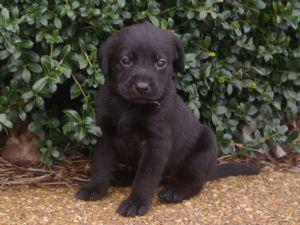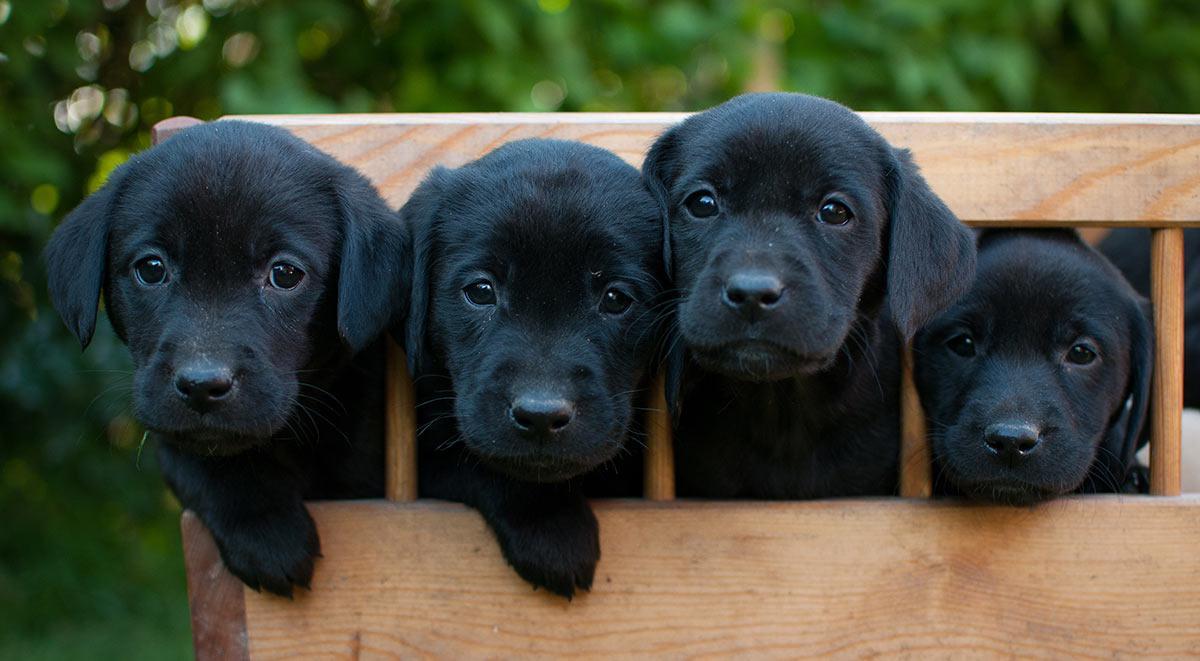The first image is the image on the left, the second image is the image on the right. Evaluate the accuracy of this statement regarding the images: "In one image, one adult dog has its mouth open showing its tongue and is wearing a collar, while a second image shows a sitting puppy of the same breed.". Is it true? Answer yes or no. No. The first image is the image on the left, the second image is the image on the right. For the images displayed, is the sentence "Left image shows a black puppy sitting upright outdoors, but not sitting directly on grass." factually correct? Answer yes or no. Yes. 